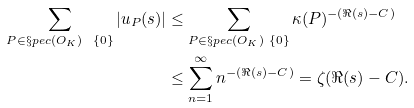Convert formula to latex. <formula><loc_0><loc_0><loc_500><loc_500>\sum _ { P \in \S p e c ( O _ { K } ) \ \{ 0 \} } | u _ { P } ( s ) | & \leq \sum _ { P \in \S p e c ( O _ { K } ) \ \{ 0 \} } \kappa ( P ) ^ { - ( \Re ( s ) - C ) } \\ & \leq \sum _ { n = 1 } ^ { \infty } n ^ { - ( \Re ( s ) - C ) } = \zeta ( \Re ( s ) - C ) .</formula> 